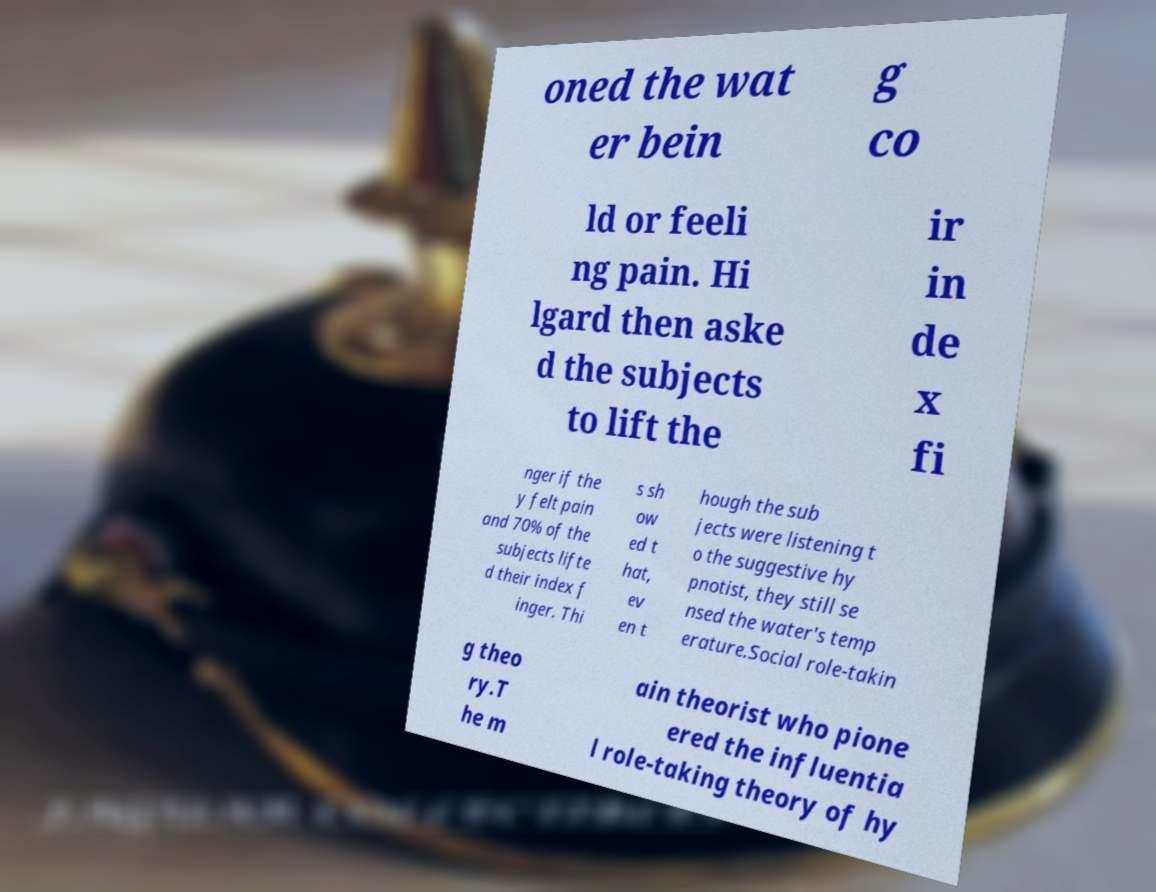Please identify and transcribe the text found in this image. oned the wat er bein g co ld or feeli ng pain. Hi lgard then aske d the subjects to lift the ir in de x fi nger if the y felt pain and 70% of the subjects lifte d their index f inger. Thi s sh ow ed t hat, ev en t hough the sub jects were listening t o the suggestive hy pnotist, they still se nsed the water's temp erature.Social role-takin g theo ry.T he m ain theorist who pione ered the influentia l role-taking theory of hy 